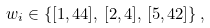Convert formula to latex. <formula><loc_0><loc_0><loc_500><loc_500>w _ { i } \in \left \{ [ 1 , 4 4 ] , \, [ 2 , 4 ] , \, [ 5 , 4 2 ] \right \} ,</formula> 